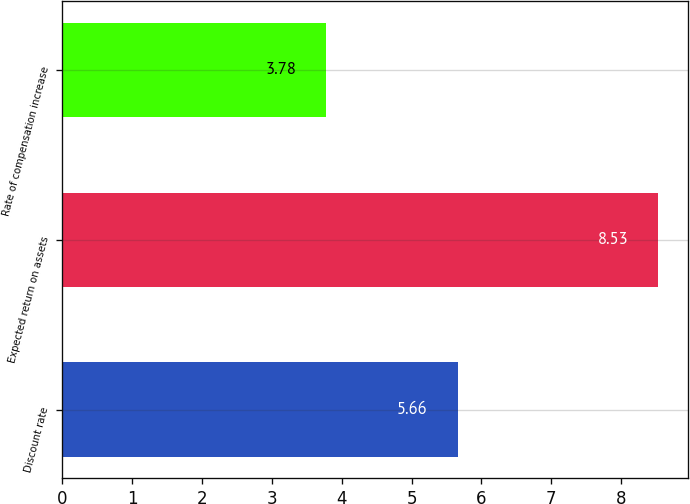Convert chart to OTSL. <chart><loc_0><loc_0><loc_500><loc_500><bar_chart><fcel>Discount rate<fcel>Expected return on assets<fcel>Rate of compensation increase<nl><fcel>5.66<fcel>8.53<fcel>3.78<nl></chart> 